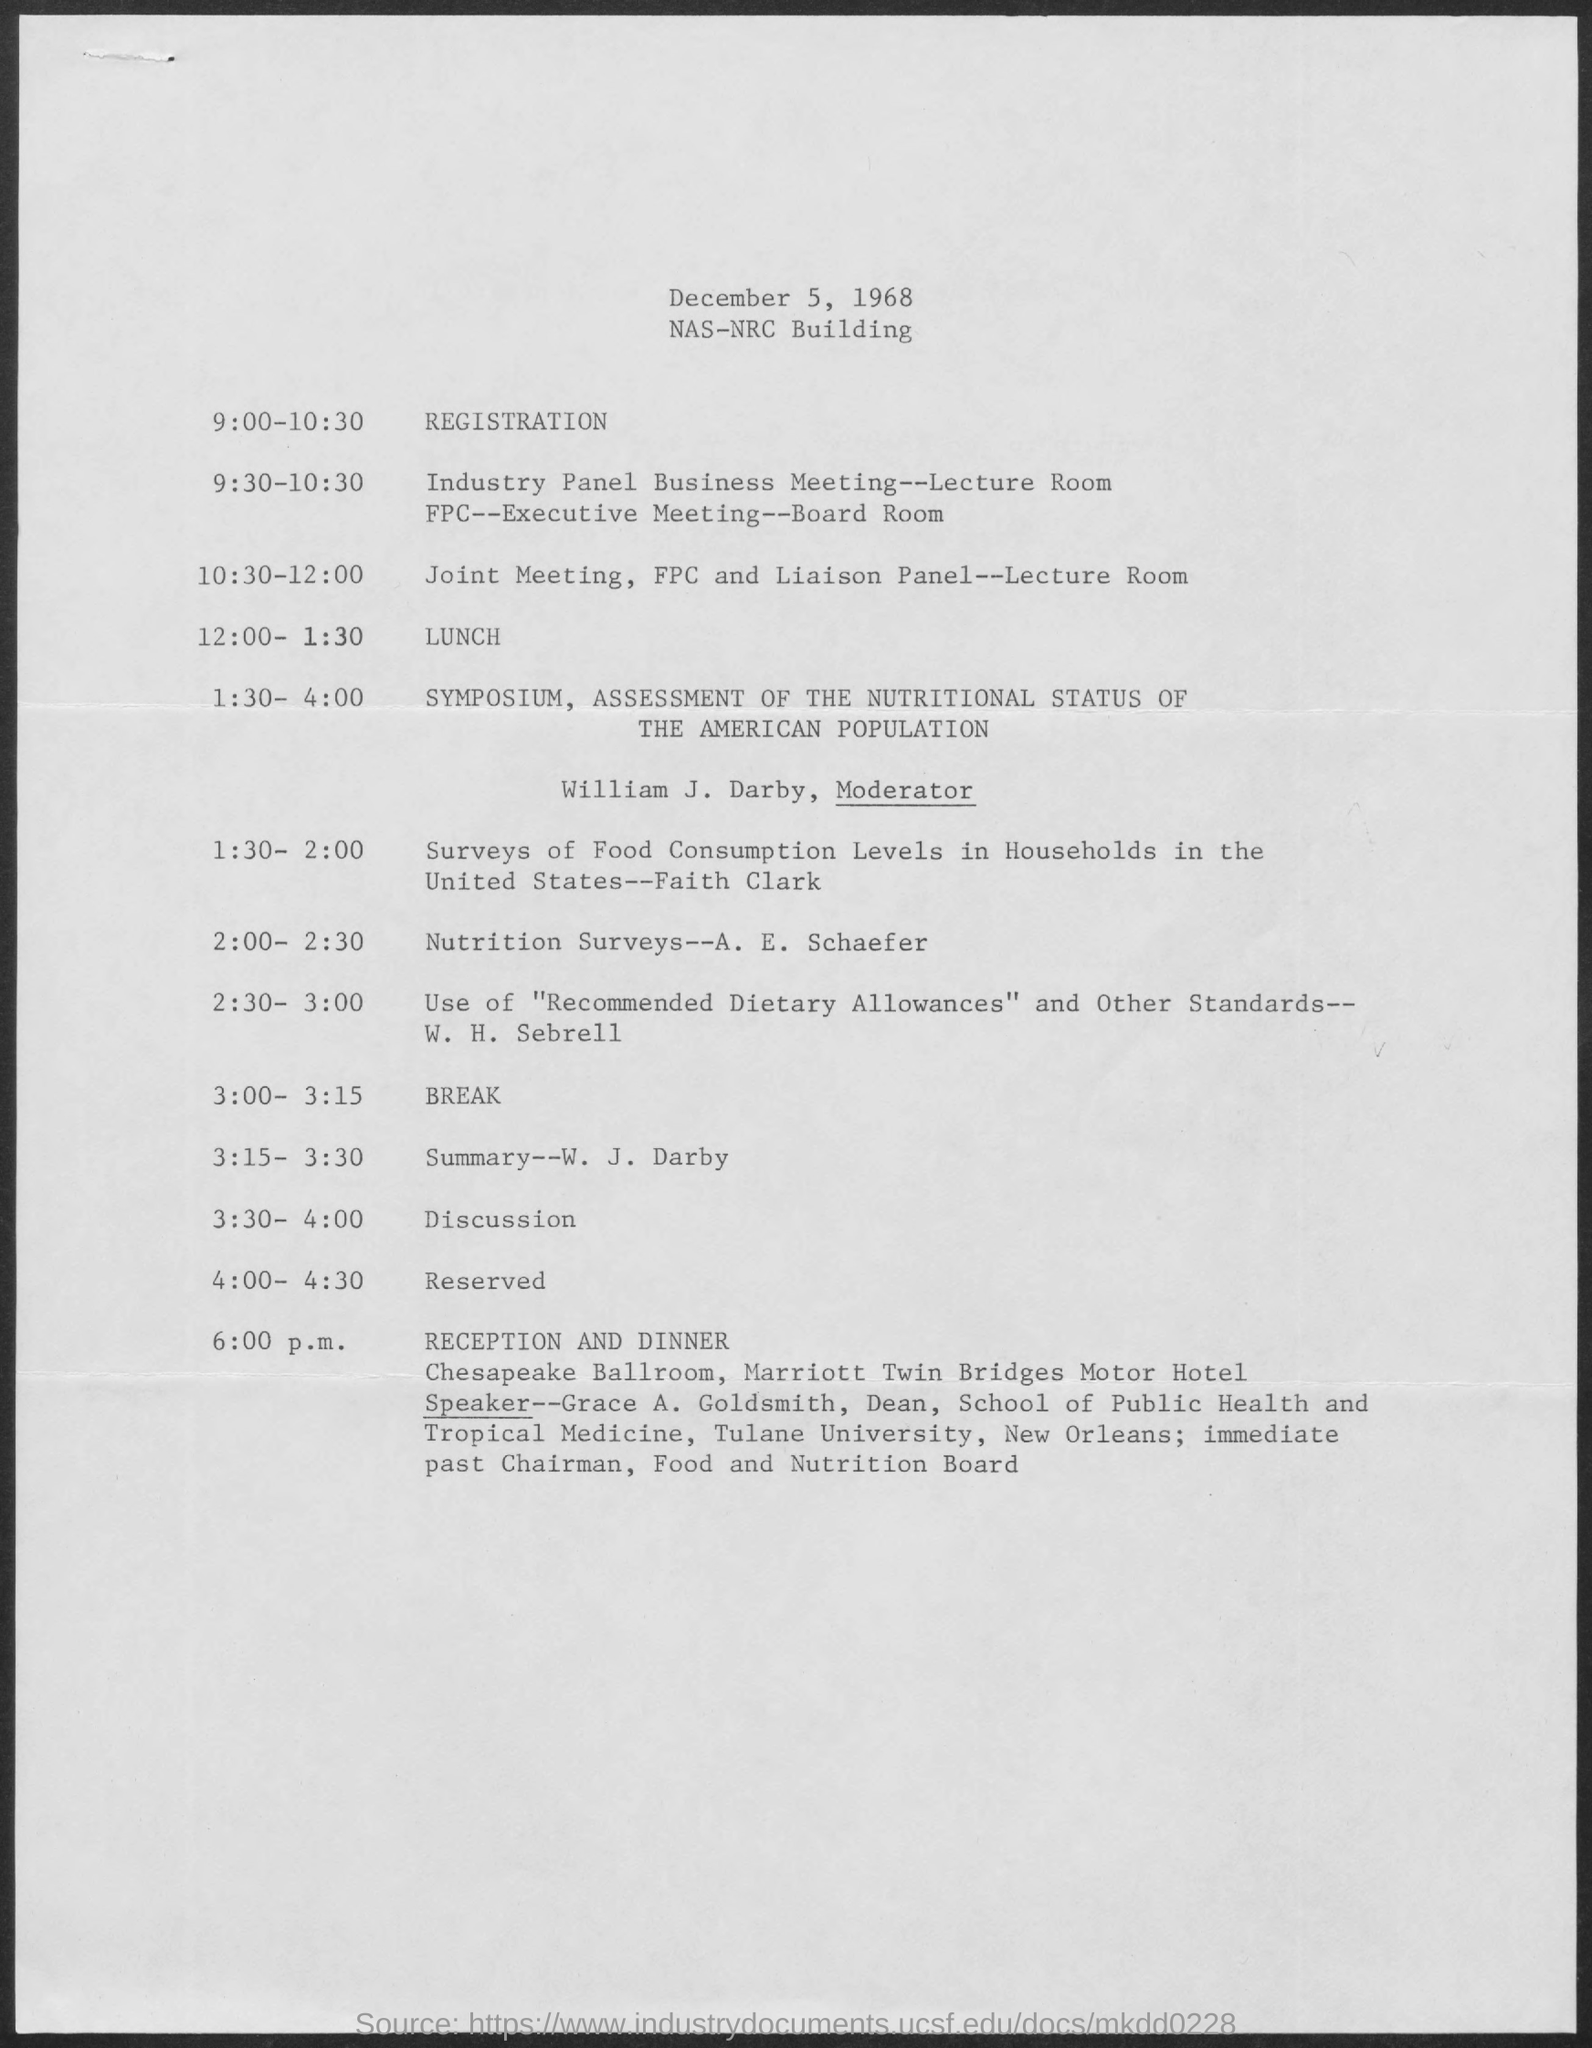Highlight a few significant elements in this photo. The speaker for the reception and dinner is Grace A. Goldsmith. The break is scheduled to occur between 3:00 and 3:15. The reception and dinner are scheduled to commence at 6:00 p.m. The moderator for the symposium on the assessment of the nutritional status of the American population is William J. Darby. The lunch will take place from 12:00 PM to 1:30 PM. 